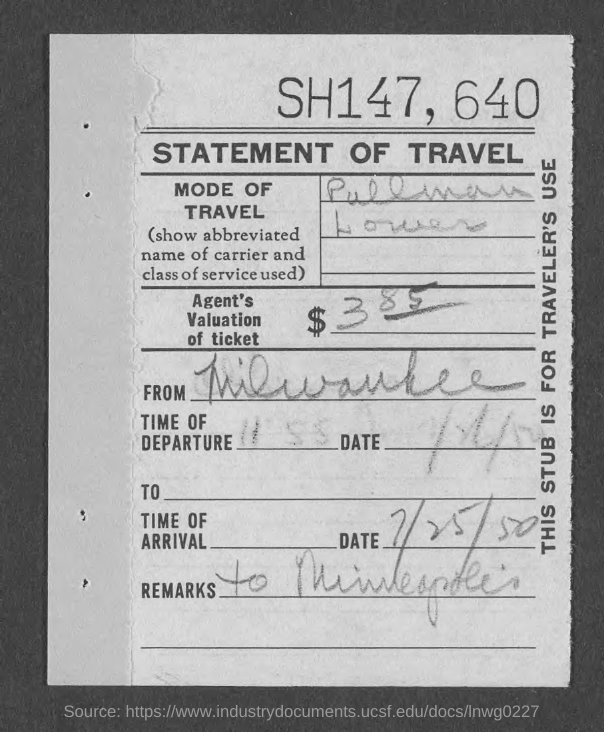Identify some key points in this picture. On what date did the individual arrive? The individual arrived on July 25, 1950. The title of the document is 'Statement of Travel'. The mode of travel was a Pullman Lower, which is a type of passenger car that was commonly used during the late 1800s to early 1900s. The destination is Minneapolis. What are the remarks? The agent has valued the ticket at $385. 